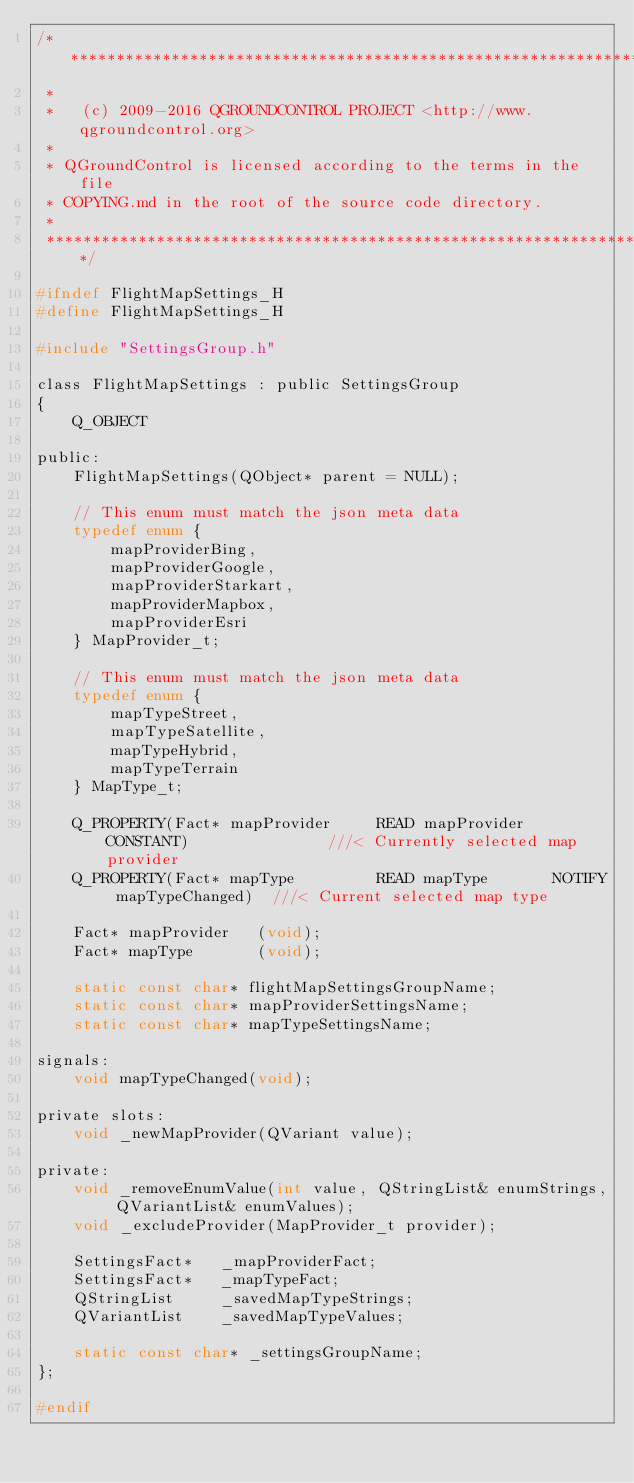Convert code to text. <code><loc_0><loc_0><loc_500><loc_500><_C_>/****************************************************************************
 *
 *   (c) 2009-2016 QGROUNDCONTROL PROJECT <http://www.qgroundcontrol.org>
 *
 * QGroundControl is licensed according to the terms in the file
 * COPYING.md in the root of the source code directory.
 *
 ****************************************************************************/

#ifndef FlightMapSettings_H
#define FlightMapSettings_H

#include "SettingsGroup.h"

class FlightMapSettings : public SettingsGroup
{
    Q_OBJECT

public:
    FlightMapSettings(QObject* parent = NULL);

    // This enum must match the json meta data
    typedef enum {
        mapProviderBing,
        mapProviderGoogle,
        mapProviderStarkart,
        mapProviderMapbox,
        mapProviderEsri
    } MapProvider_t;

    // This enum must match the json meta data
    typedef enum {
        mapTypeStreet,
        mapTypeSatellite,
        mapTypeHybrid,
        mapTypeTerrain
    } MapType_t;

    Q_PROPERTY(Fact* mapProvider     READ mapProvider   CONSTANT)               ///< Currently selected map provider
    Q_PROPERTY(Fact* mapType         READ mapType       NOTIFY mapTypeChanged)  ///< Current selected map type

    Fact* mapProvider   (void);
    Fact* mapType       (void);

    static const char* flightMapSettingsGroupName;
    static const char* mapProviderSettingsName;
    static const char* mapTypeSettingsName;

signals:
    void mapTypeChanged(void);

private slots:
    void _newMapProvider(QVariant value);

private:
    void _removeEnumValue(int value, QStringList& enumStrings, QVariantList& enumValues);
    void _excludeProvider(MapProvider_t provider);

    SettingsFact*   _mapProviderFact;
    SettingsFact*   _mapTypeFact;
    QStringList     _savedMapTypeStrings;
    QVariantList    _savedMapTypeValues;

    static const char* _settingsGroupName;
};

#endif
</code> 